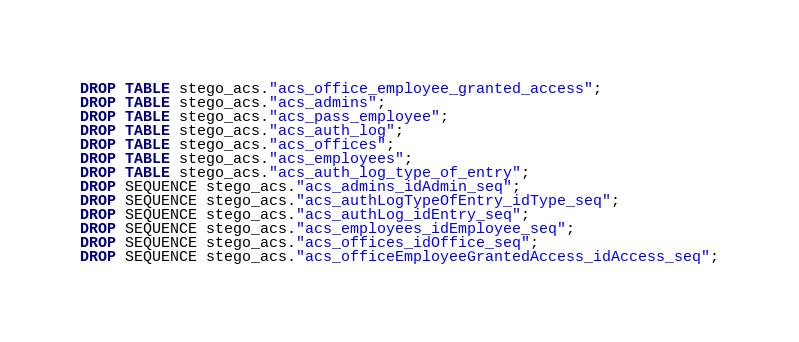<code> <loc_0><loc_0><loc_500><loc_500><_SQL_>DROP TABLE stego_acs."acs_office_employee_granted_access";
DROP TABLE stego_acs."acs_admins";
DROP TABLE stego_acs."acs_pass_employee";
DROP TABLE stego_acs."acs_auth_log";
DROP TABLE stego_acs."acs_offices";
DROP TABLE stego_acs."acs_employees";
DROP TABLE stego_acs."acs_auth_log_type_of_entry";
DROP SEQUENCE stego_acs."acs_admins_idAdmin_seq";
DROP SEQUENCE stego_acs."acs_authLogTypeOfEntry_idType_seq";
DROP SEQUENCE stego_acs."acs_authLog_idEntry_seq";
DROP SEQUENCE stego_acs."acs_employees_idEmployee_seq";
DROP SEQUENCE stego_acs."acs_offices_idOffice_seq";
DROP SEQUENCE stego_acs."acs_officeEmployeeGrantedAccess_idAccess_seq";
</code> 